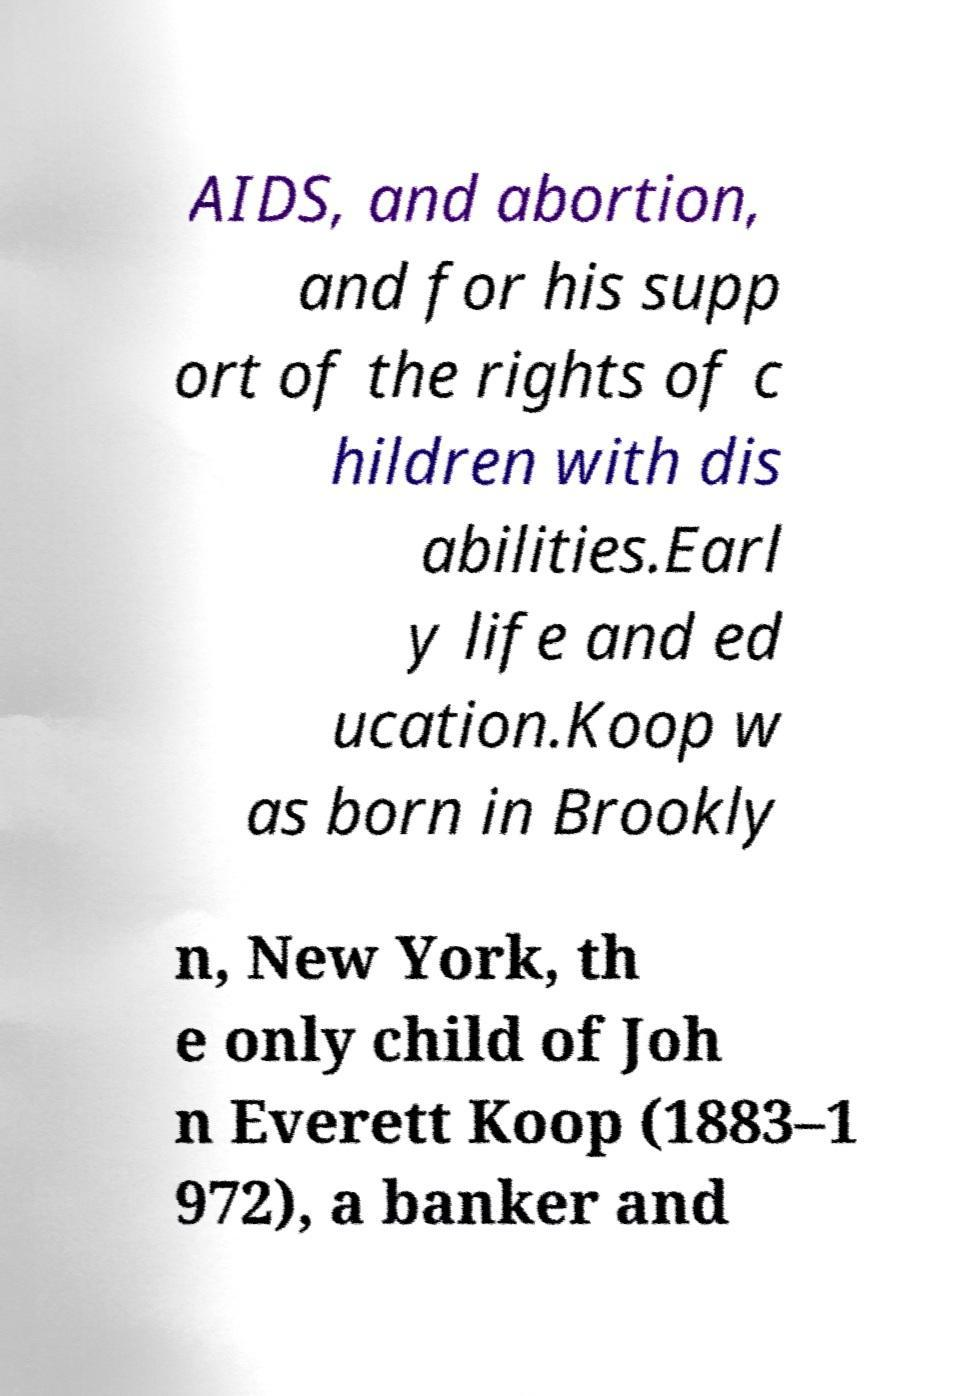Could you assist in decoding the text presented in this image and type it out clearly? AIDS, and abortion, and for his supp ort of the rights of c hildren with dis abilities.Earl y life and ed ucation.Koop w as born in Brookly n, New York, th e only child of Joh n Everett Koop (1883–1 972), a banker and 